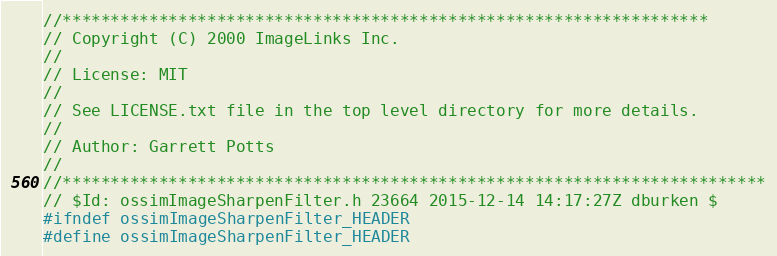Convert code to text. <code><loc_0><loc_0><loc_500><loc_500><_C_>//*******************************************************************
// Copyright (C) 2000 ImageLinks Inc. 
//
// License: MIT
// 
// See LICENSE.txt file in the top level directory for more details.
//
// Author: Garrett Potts
//
//*************************************************************************
// $Id: ossimImageSharpenFilter.h 23664 2015-12-14 14:17:27Z dburken $
#ifndef ossimImageSharpenFilter_HEADER
#define ossimImageSharpenFilter_HEADER</code> 